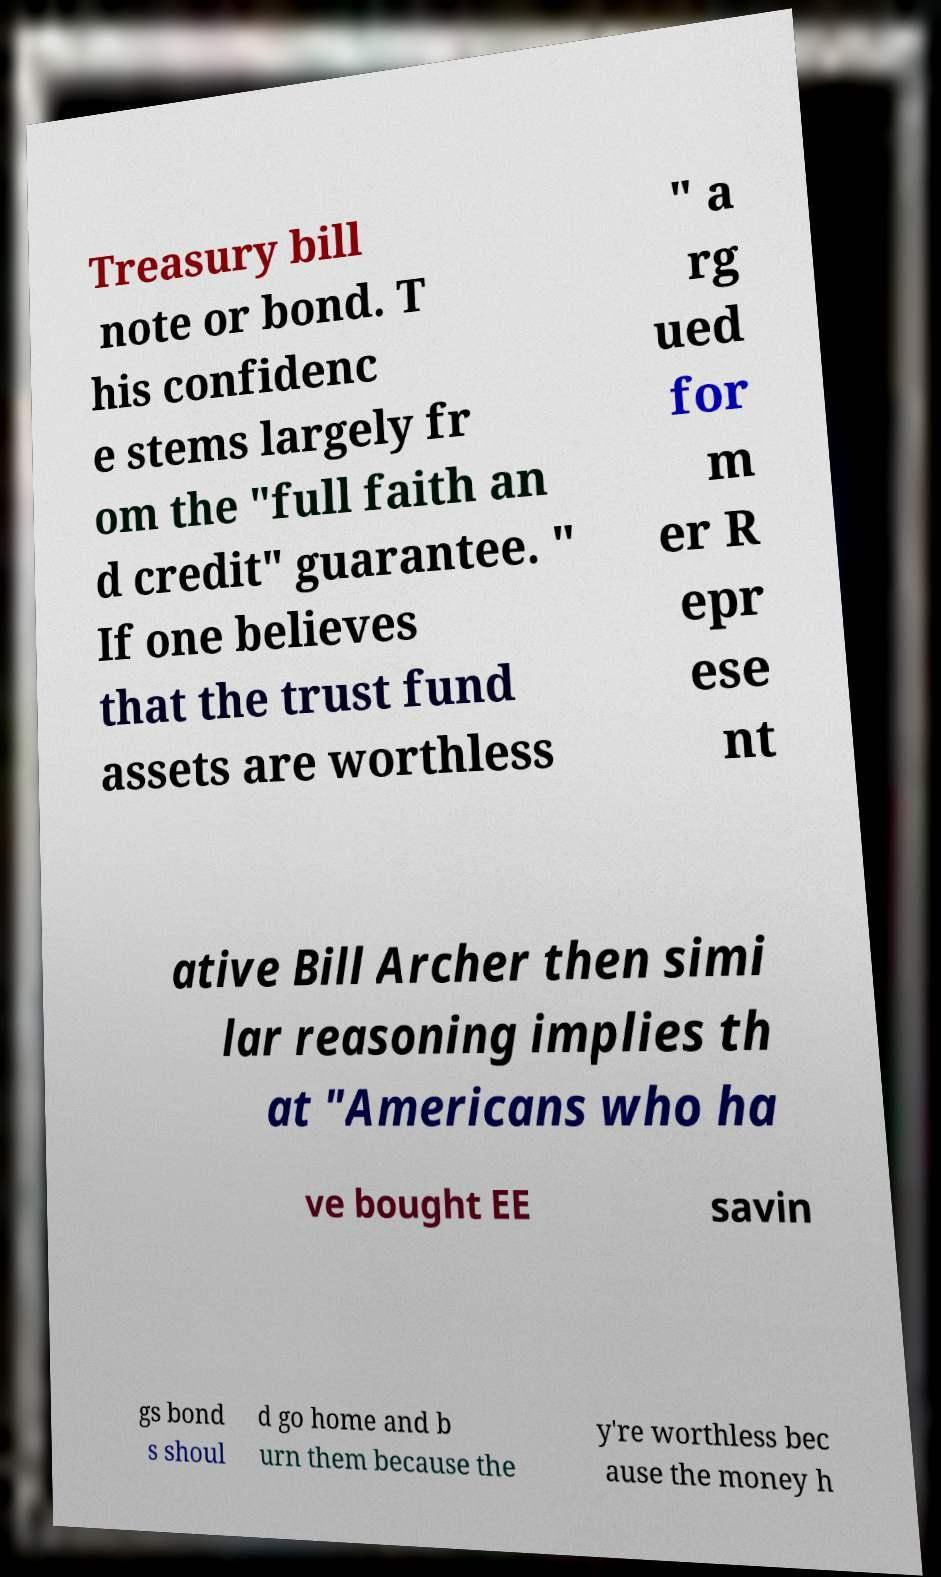Please identify and transcribe the text found in this image. Treasury bill note or bond. T his confidenc e stems largely fr om the "full faith an d credit" guarantee. " If one believes that the trust fund assets are worthless " a rg ued for m er R epr ese nt ative Bill Archer then simi lar reasoning implies th at "Americans who ha ve bought EE savin gs bond s shoul d go home and b urn them because the y're worthless bec ause the money h 